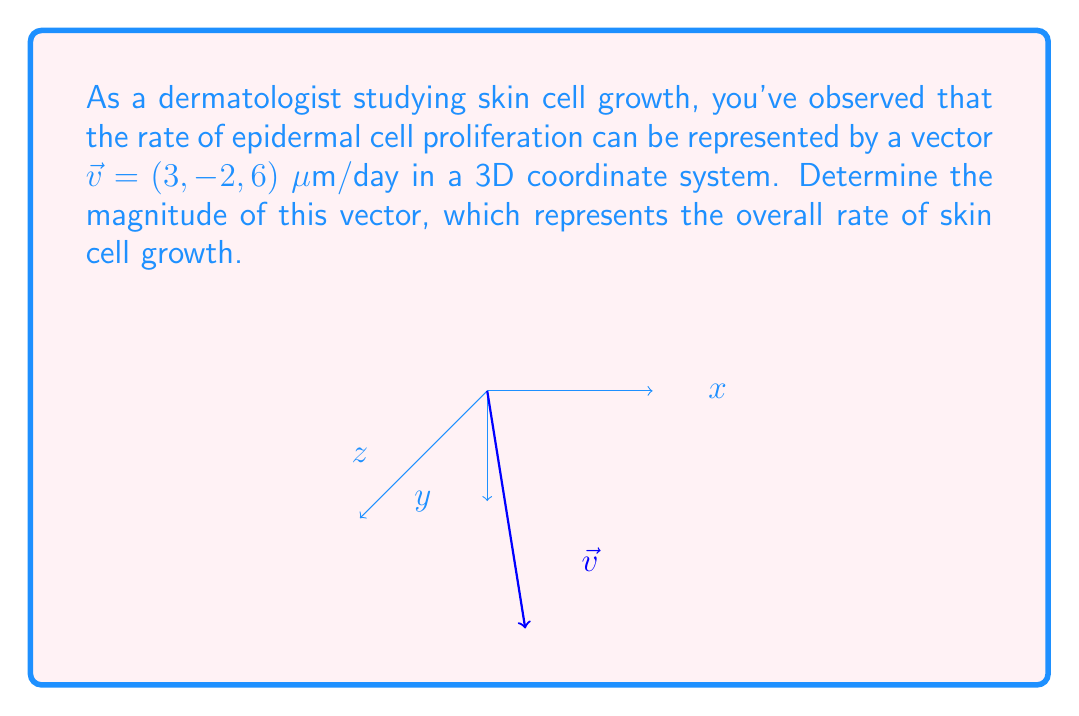Help me with this question. To find the magnitude of the vector $\vec{v} = (3, -2, 6)$, we need to calculate its length using the Euclidean norm formula:

1) The magnitude of a 3D vector $\vec{v} = (x, y, z)$ is given by:
   $$\|\vec{v}\| = \sqrt{x^2 + y^2 + z^2}$$

2) Substituting the values:
   $$\|\vec{v}\| = \sqrt{3^2 + (-2)^2 + 6^2}$$

3) Simplify the expressions under the square root:
   $$\|\vec{v}\| = \sqrt{9 + 4 + 36}$$

4) Add the terms under the square root:
   $$\|\vec{v}\| = \sqrt{49}$$

5) Simplify the square root:
   $$\|\vec{v}\| = 7$$

Therefore, the magnitude of the vector representing the rate of skin cell growth is 7 μm/day.
Answer: $7$ μm/day 